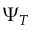<formula> <loc_0><loc_0><loc_500><loc_500>\Psi _ { T }</formula> 